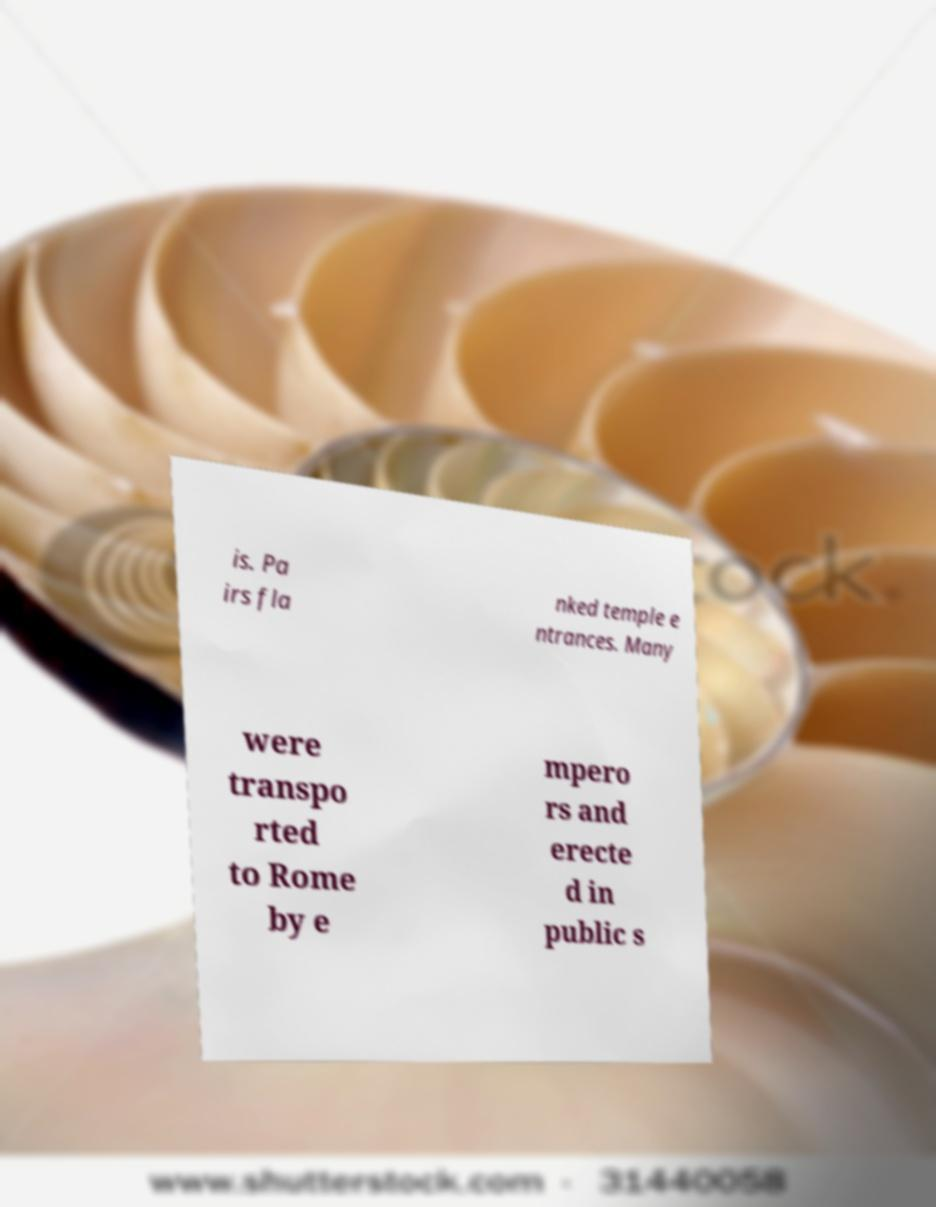Could you assist in decoding the text presented in this image and type it out clearly? is. Pa irs fla nked temple e ntrances. Many were transpo rted to Rome by e mpero rs and erecte d in public s 